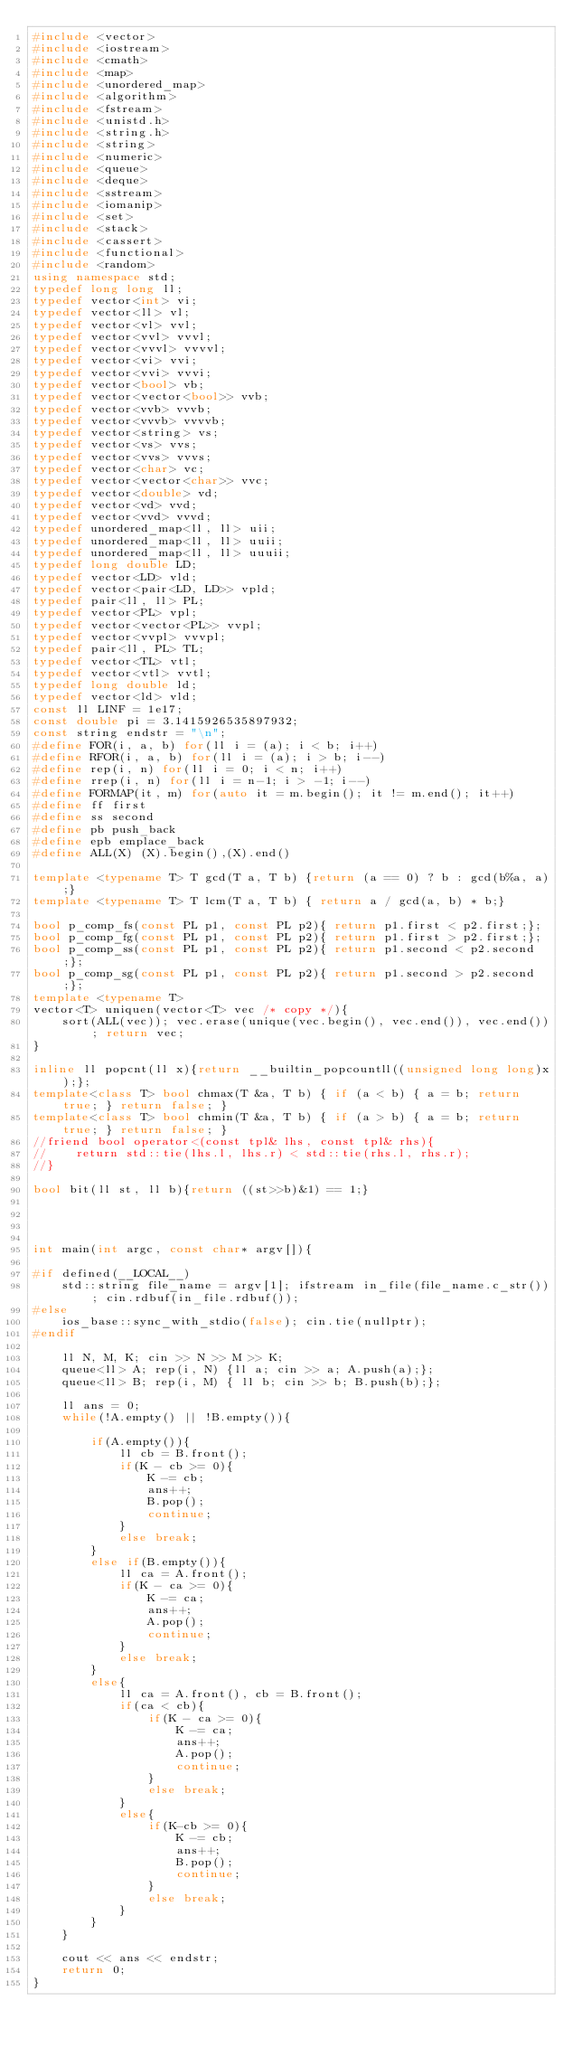<code> <loc_0><loc_0><loc_500><loc_500><_C++_>#include <vector>
#include <iostream>
#include <cmath>
#include <map>
#include <unordered_map>
#include <algorithm>
#include <fstream>
#include <unistd.h>
#include <string.h>
#include <string>
#include <numeric>
#include <queue>
#include <deque>
#include <sstream>
#include <iomanip>
#include <set>
#include <stack>
#include <cassert>
#include <functional>
#include <random>
using namespace std;
typedef long long ll;
typedef vector<int> vi;
typedef vector<ll> vl;
typedef vector<vl> vvl;
typedef vector<vvl> vvvl;
typedef vector<vvvl> vvvvl;
typedef vector<vi> vvi;
typedef vector<vvi> vvvi;
typedef vector<bool> vb;
typedef vector<vector<bool>> vvb;
typedef vector<vvb> vvvb;
typedef vector<vvvb> vvvvb;
typedef vector<string> vs;
typedef vector<vs> vvs;
typedef vector<vvs> vvvs;
typedef vector<char> vc;
typedef vector<vector<char>> vvc;
typedef vector<double> vd;
typedef vector<vd> vvd;
typedef vector<vvd> vvvd;
typedef unordered_map<ll, ll> uii;
typedef unordered_map<ll, ll> uuii;
typedef unordered_map<ll, ll> uuuii;
typedef long double LD;
typedef vector<LD> vld;
typedef vector<pair<LD, LD>> vpld;
typedef pair<ll, ll> PL;
typedef vector<PL> vpl;
typedef vector<vector<PL>> vvpl;
typedef vector<vvpl> vvvpl;
typedef pair<ll, PL> TL;
typedef vector<TL> vtl;
typedef vector<vtl> vvtl;
typedef long double ld;
typedef vector<ld> vld;
const ll LINF = 1e17;
const double pi = 3.1415926535897932;
const string endstr = "\n";
#define FOR(i, a, b) for(ll i = (a); i < b; i++)
#define RFOR(i, a, b) for(ll i = (a); i > b; i--)
#define rep(i, n) for(ll i = 0; i < n; i++)
#define rrep(i, n) for(ll i = n-1; i > -1; i--)
#define FORMAP(it, m) for(auto it = m.begin(); it != m.end(); it++)
#define ff first
#define ss second
#define pb push_back
#define epb emplace_back
#define ALL(X) (X).begin(),(X).end()

template <typename T> T gcd(T a, T b) {return (a == 0) ? b : gcd(b%a, a);}
template <typename T> T lcm(T a, T b) { return a / gcd(a, b) * b;}

bool p_comp_fs(const PL p1, const PL p2){ return p1.first < p2.first;};
bool p_comp_fg(const PL p1, const PL p2){ return p1.first > p2.first;};
bool p_comp_ss(const PL p1, const PL p2){ return p1.second < p2.second;};
bool p_comp_sg(const PL p1, const PL p2){ return p1.second > p2.second;};
template <typename T>
vector<T> uniquen(vector<T> vec /* copy */){
    sort(ALL(vec)); vec.erase(unique(vec.begin(), vec.end()), vec.end()); return vec;
}

inline ll popcnt(ll x){return __builtin_popcountll((unsigned long long)x);};
template<class T> bool chmax(T &a, T b) { if (a < b) { a = b; return true; } return false; }
template<class T> bool chmin(T &a, T b) { if (a > b) { a = b; return true; } return false; }
//friend bool operator<(const tpl& lhs, const tpl& rhs){
//    return std::tie(lhs.l, lhs.r) < std::tie(rhs.l, rhs.r);
//}

bool bit(ll st, ll b){return ((st>>b)&1) == 1;}




int main(int argc, const char* argv[]){

#if defined(__LOCAL__)
    std::string file_name = argv[1]; ifstream in_file(file_name.c_str()); cin.rdbuf(in_file.rdbuf());
#else
    ios_base::sync_with_stdio(false); cin.tie(nullptr);
#endif

    ll N, M, K; cin >> N >> M >> K;
    queue<ll> A; rep(i, N) {ll a; cin >> a; A.push(a);};
    queue<ll> B; rep(i, M) { ll b; cin >> b; B.push(b);};

    ll ans = 0;
    while(!A.empty() || !B.empty()){
        
        if(A.empty()){
            ll cb = B.front();
            if(K - cb >= 0){
                K -= cb;
                ans++;
                B.pop();
                continue;
            }
            else break;
        }
        else if(B.empty()){
            ll ca = A.front();
            if(K - ca >= 0){
                K -= ca;
                ans++;
                A.pop();
                continue;
            }
            else break;
        }
        else{
            ll ca = A.front(), cb = B.front();
            if(ca < cb){
                if(K - ca >= 0){
                    K -= ca;
                    ans++;
                    A.pop();
                    continue;
                }
                else break;
            }
            else{
                if(K-cb >= 0){
                    K -= cb;
                    ans++;
                    B.pop();
                    continue;
                }
                else break;
            }
        }
    }
    
    cout << ans << endstr;
    return 0;
}</code> 